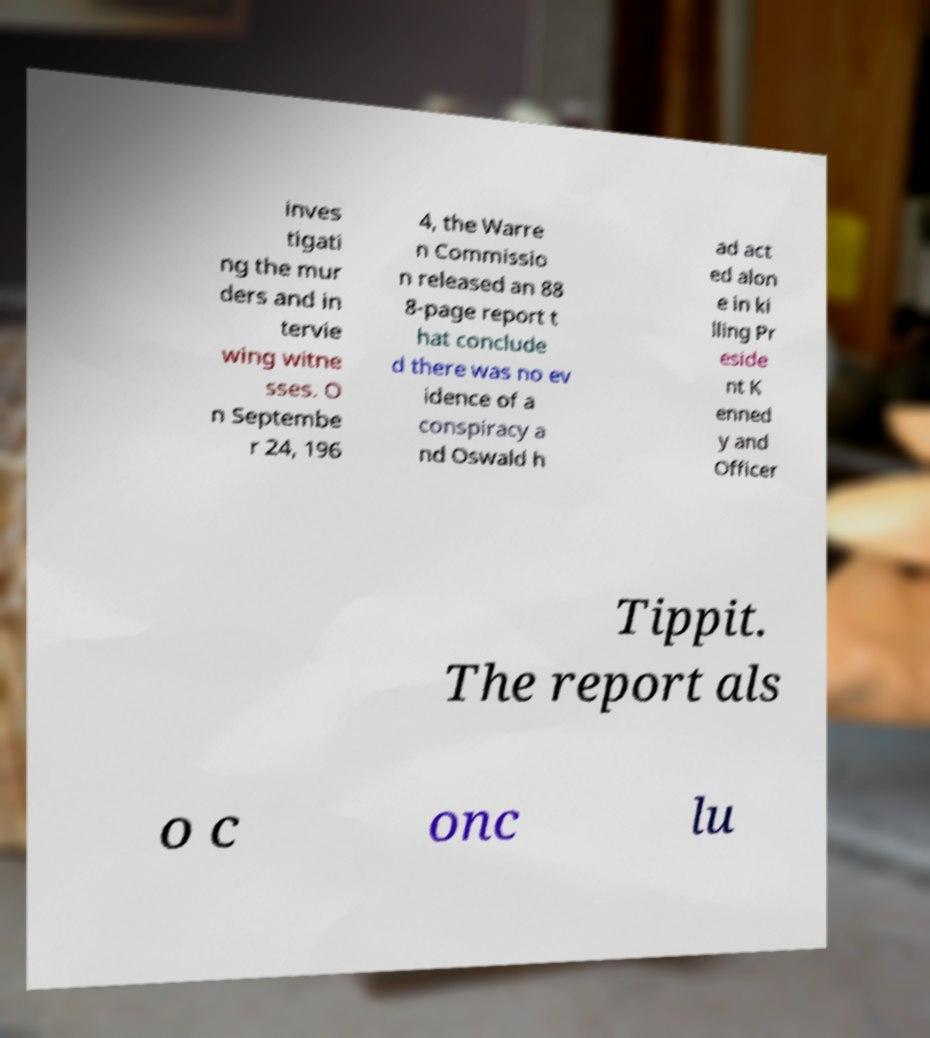Please read and relay the text visible in this image. What does it say? inves tigati ng the mur ders and in tervie wing witne sses. O n Septembe r 24, 196 4, the Warre n Commissio n released an 88 8-page report t hat conclude d there was no ev idence of a conspiracy a nd Oswald h ad act ed alon e in ki lling Pr eside nt K enned y and Officer Tippit. The report als o c onc lu 